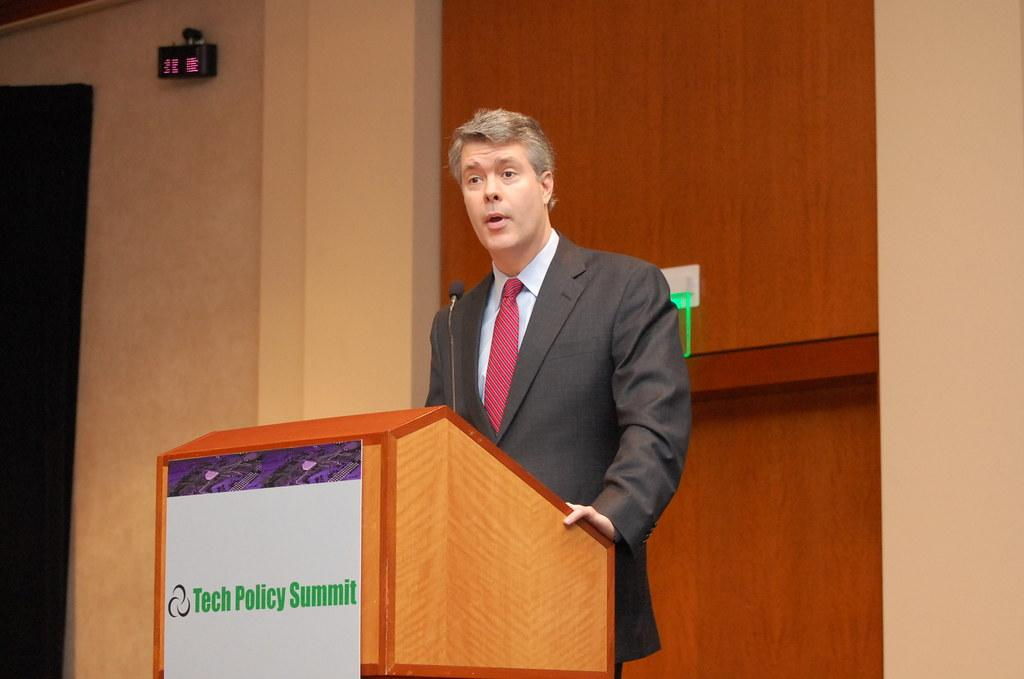Who is the main subject in the image? There is a man in the image. What is the man doing near the podium? The man is standing near a podium. What is the man wearing? The man is wearing a black suit. What is the man doing while standing near the podium? The man is talking. What can be seen in the background of the image? There is a wall with pillars in the background of the image. What is the podium made of? The podium is made of wood. How many beds are visible in the image? There are no beds present in the image. What type of dirt is being used to clean the podium in the image? There is no dirt being used to clean the podium in the image; the podium is made of wood and the man is talking near it. 